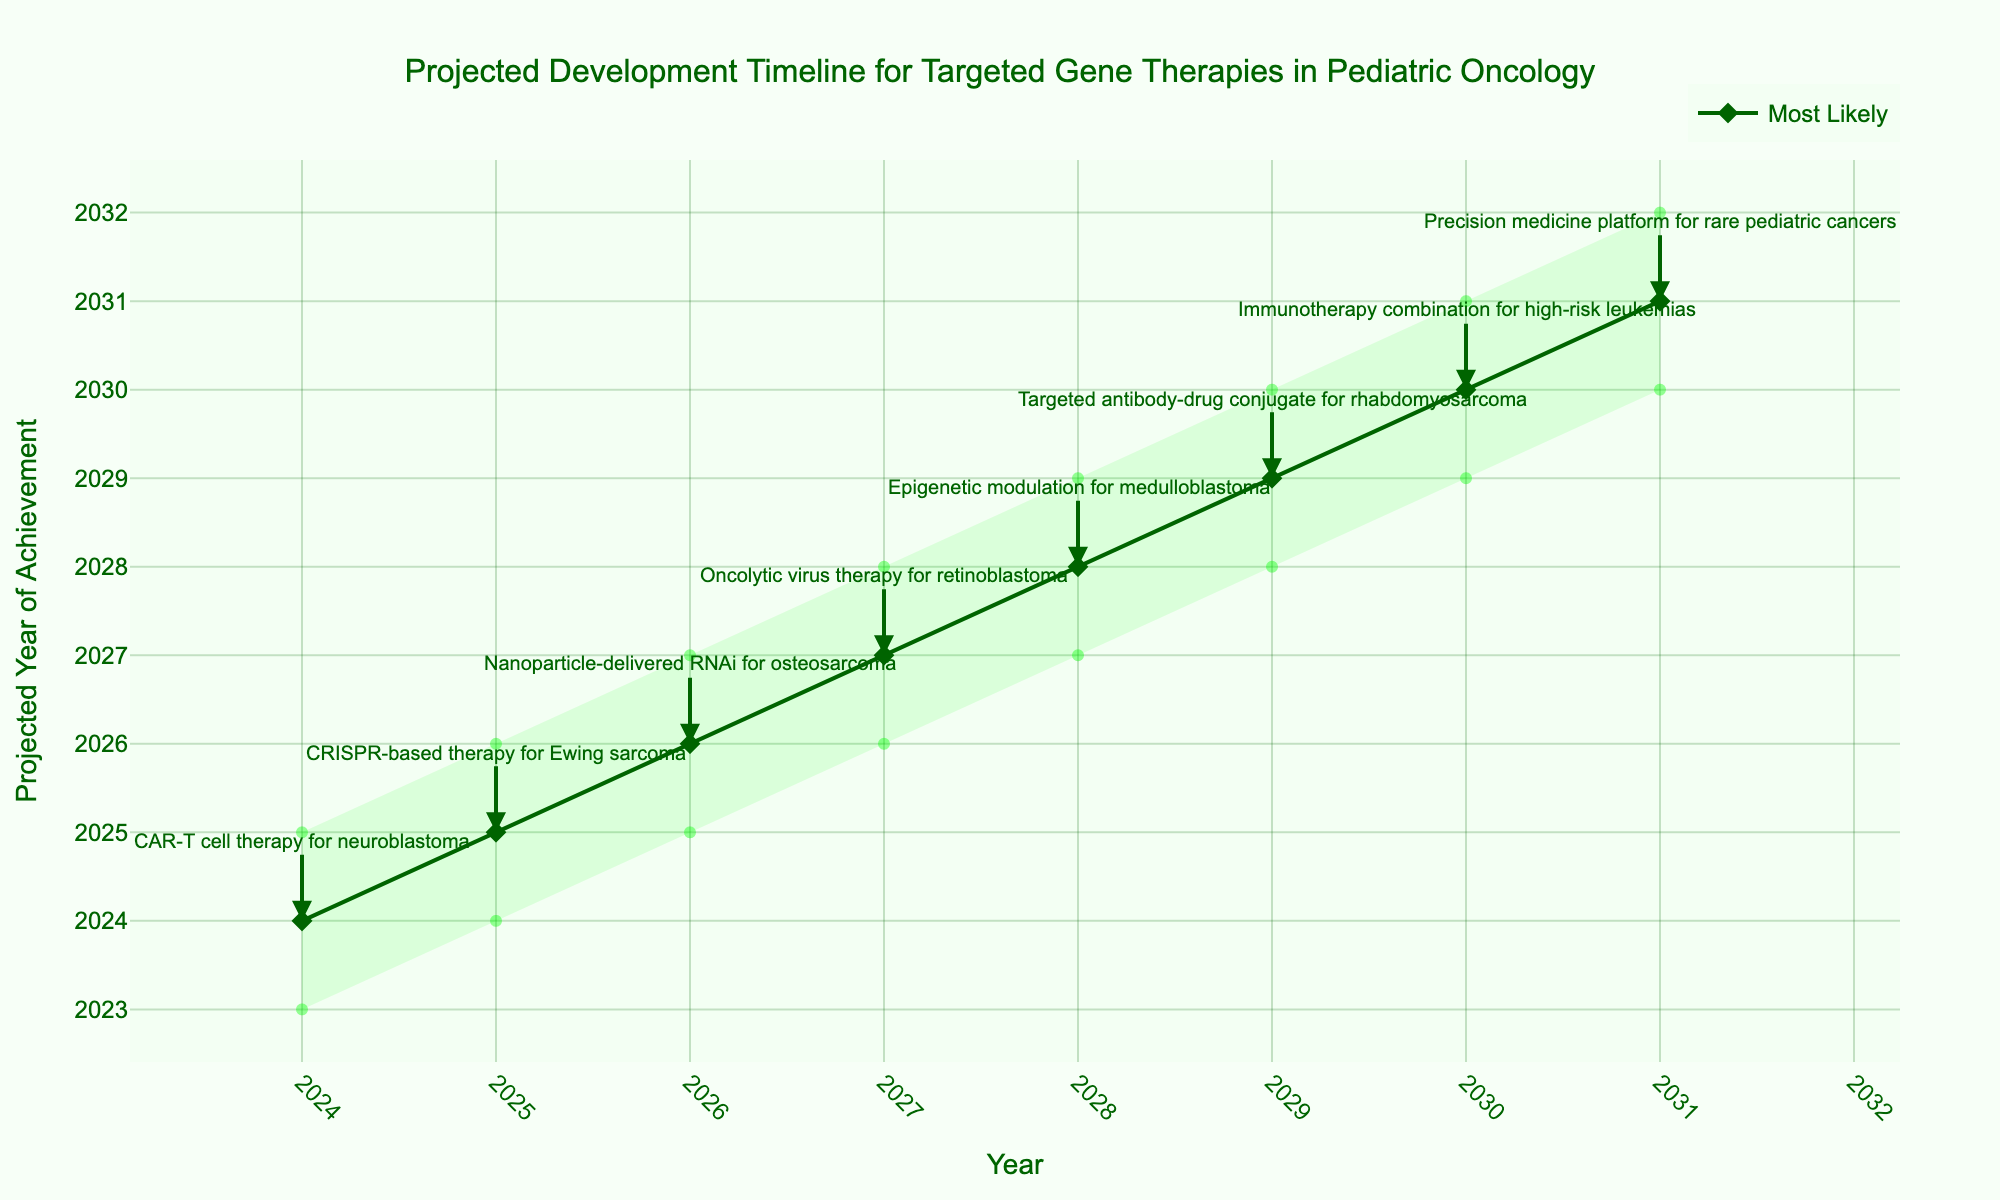What is the title of the figure? The title is located at the top of the figure, and it is usually the largest and most prominent text.
Answer: Projected Development Timeline for Targeted Gene Therapies in Pediatric Oncology What is the projected year for CAR-T cell therapy targeting neuroblastoma under optimistic conditions? From the "Optimistic" trace, locate the year corresponding to CAR-T cell therapy for neuroblastoma, which is shown on the leftmost part of the projections.
Answer: 2023 Which milestone is projected to be achieved in 2028 according to the most likely scenario? Look along the "Most Likely" trace and find the year 2028. Then, identify the milestone indicated at that point.
Answer: Epigenetic modulation for medulloblastoma How do the optimistic and pessimistic timelines for nanoparticle-delivered RNAi for osteosarcoma differ? Compare the years given in the "Optimistic" and "Pessimistic" traces for the milestone nanoparticle-delivered RNAi for osteosarcoma. Subtract the earlier year from the later one.
Answer: 2 years What is the most likely year for CRISPR-based therapy for Ewing sarcoma? Find the marker on the "Most Likely" trace associated with CRISPR-based therapy for Ewing sarcoma by looking at the annotations on the graph.
Answer: 2025 Which milestone has the widest range between the optimistic and pessimistic projections? Calculate the range (difference) between optimistic and pessimistic years for each milestone and determine which has the largest value.
Answer: Immunotherapy combination for high-risk leukemias Compare the optimistic projections for CAR-T cell therapy for neuroblastoma and oncolytic virus therapy for retinoblastoma. Which is earlier? Locate and compare the years of the "Optimistic" trace for both CAR-T cell therapy for neuroblastoma and oncolytic virus therapy for retinoblastoma.
Answer: CAR-T cell therapy for neuroblastoma How many years are projected for the achievement of all milestones from the most optimistic to the most pessimistic case? Identify the earliest and latest years in the "Optimistic" and "Pessimistic" traces respectively, then calculate the difference between the two.
Answer: 9 years (2023-2032) What can be inferred about the trend in the development timeline from 2024 to 2031? Observe the progression and pattern of the "Most Likely" trace from the year 2024 to 2031 to identify any upward, downward, or stable trends.
Answer: The milestones show a steady yearly progression Which milestone is projected to be achieved the latest according to the most likely scenario? Find the rightmost annotation on the "Most Likely" trace to identify the latest projected milestone.
Answer: Precision medicine platform for rare pediatric cancers 